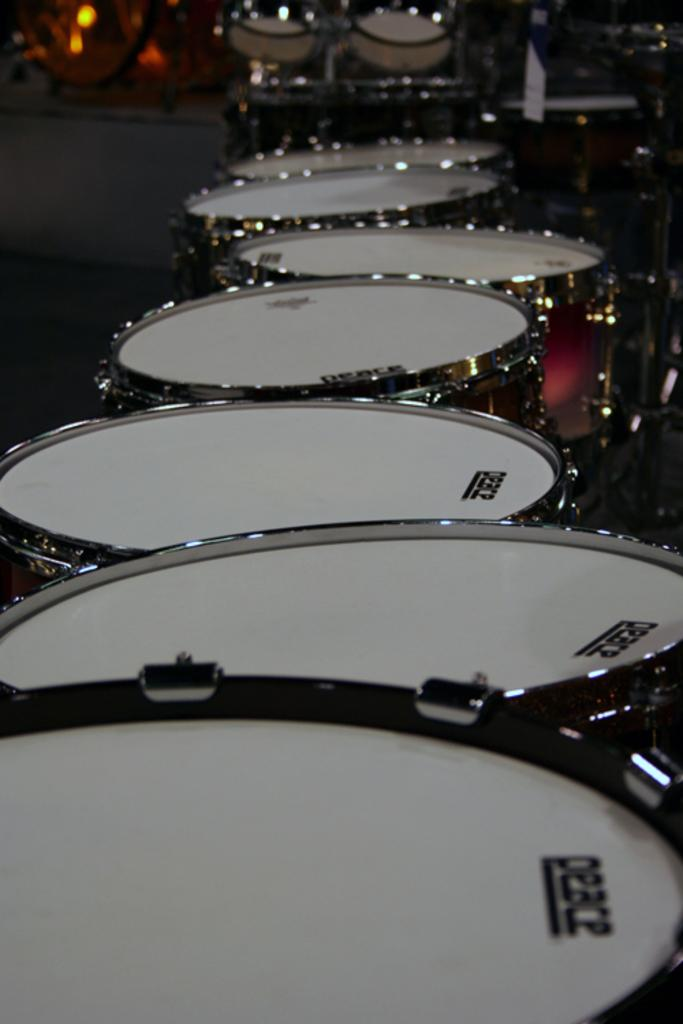What is present on the floor in the image? There are many drugs placed on the floor in the image. Can you describe the arrangement of the drugs on the floor? The provided facts do not give information about the arrangement of the drugs on the floor. What type of chair is present in the image? There is no chair present in the image; it only features drugs placed on the floor. What account number is associated with the drugs in the image? There is no account number associated with the drugs in the image, as it is a visual representation and not a financial transaction. 